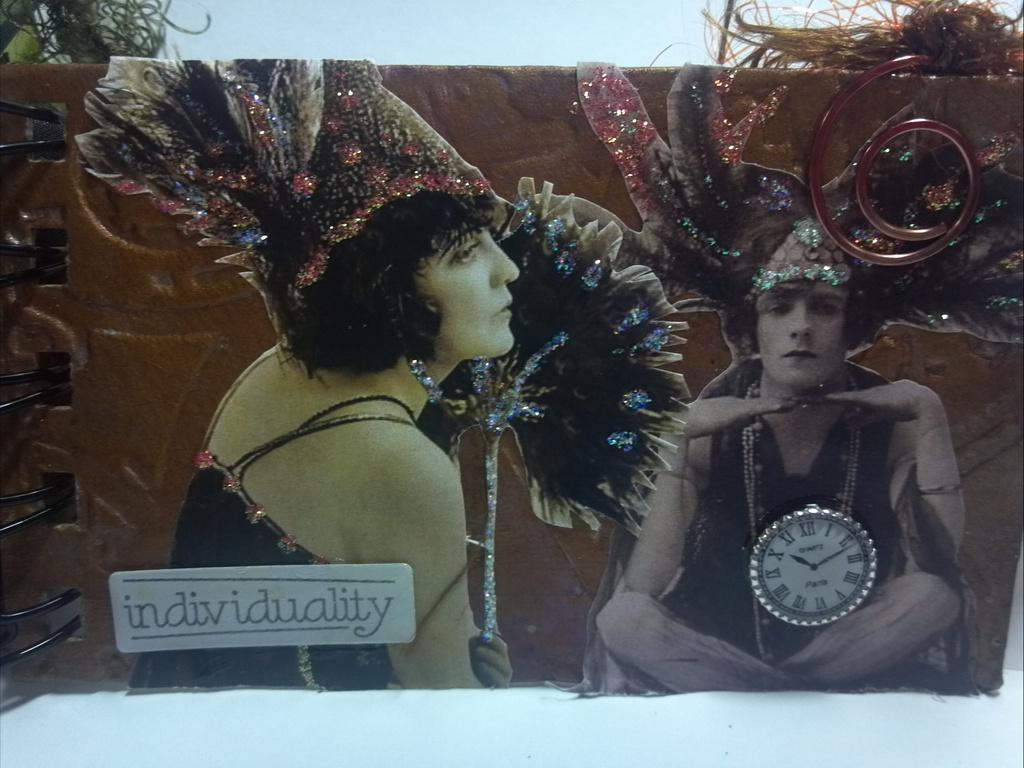Provide a one-sentence caption for the provided image. Sign that shows two people and the word "individuality" under them. 